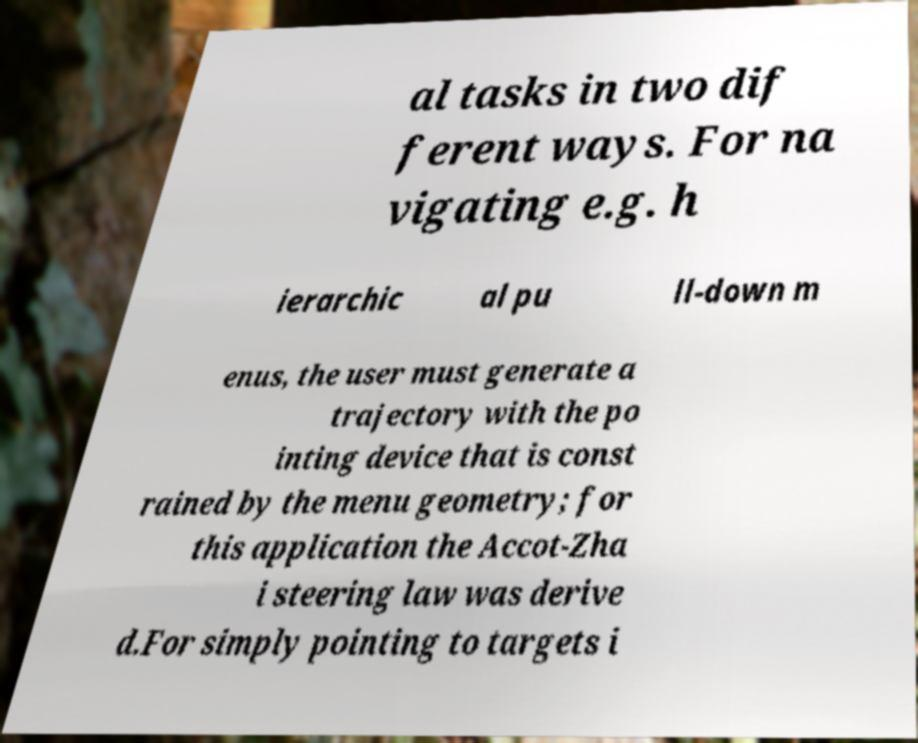For documentation purposes, I need the text within this image transcribed. Could you provide that? al tasks in two dif ferent ways. For na vigating e.g. h ierarchic al pu ll-down m enus, the user must generate a trajectory with the po inting device that is const rained by the menu geometry; for this application the Accot-Zha i steering law was derive d.For simply pointing to targets i 